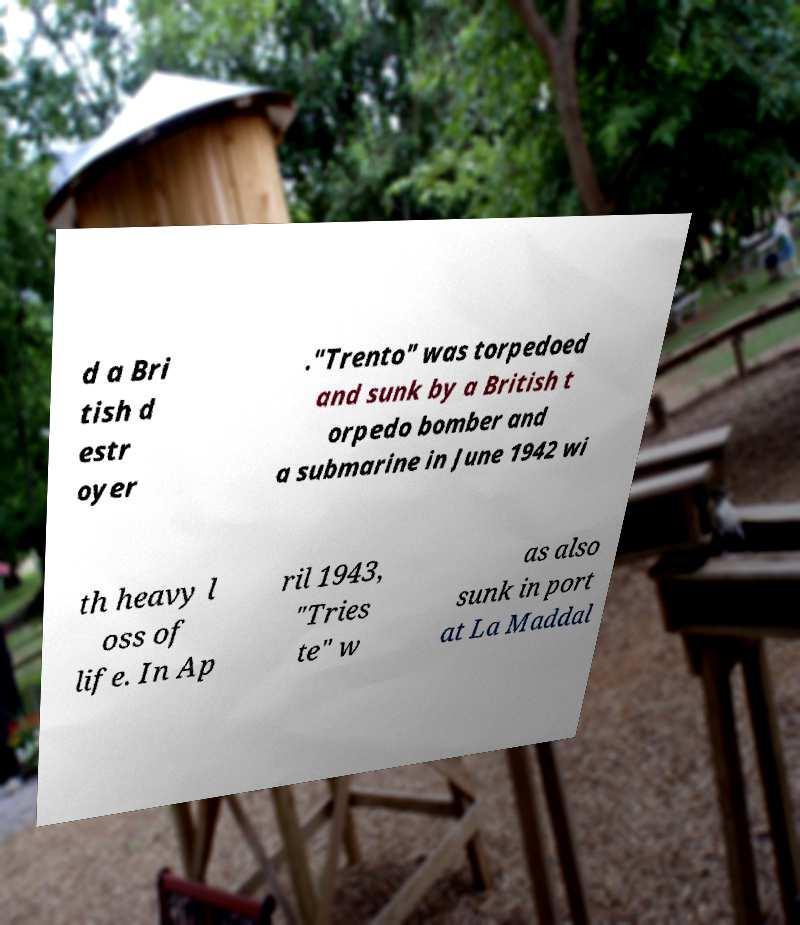What messages or text are displayed in this image? I need them in a readable, typed format. d a Bri tish d estr oyer ."Trento" was torpedoed and sunk by a British t orpedo bomber and a submarine in June 1942 wi th heavy l oss of life. In Ap ril 1943, "Tries te" w as also sunk in port at La Maddal 